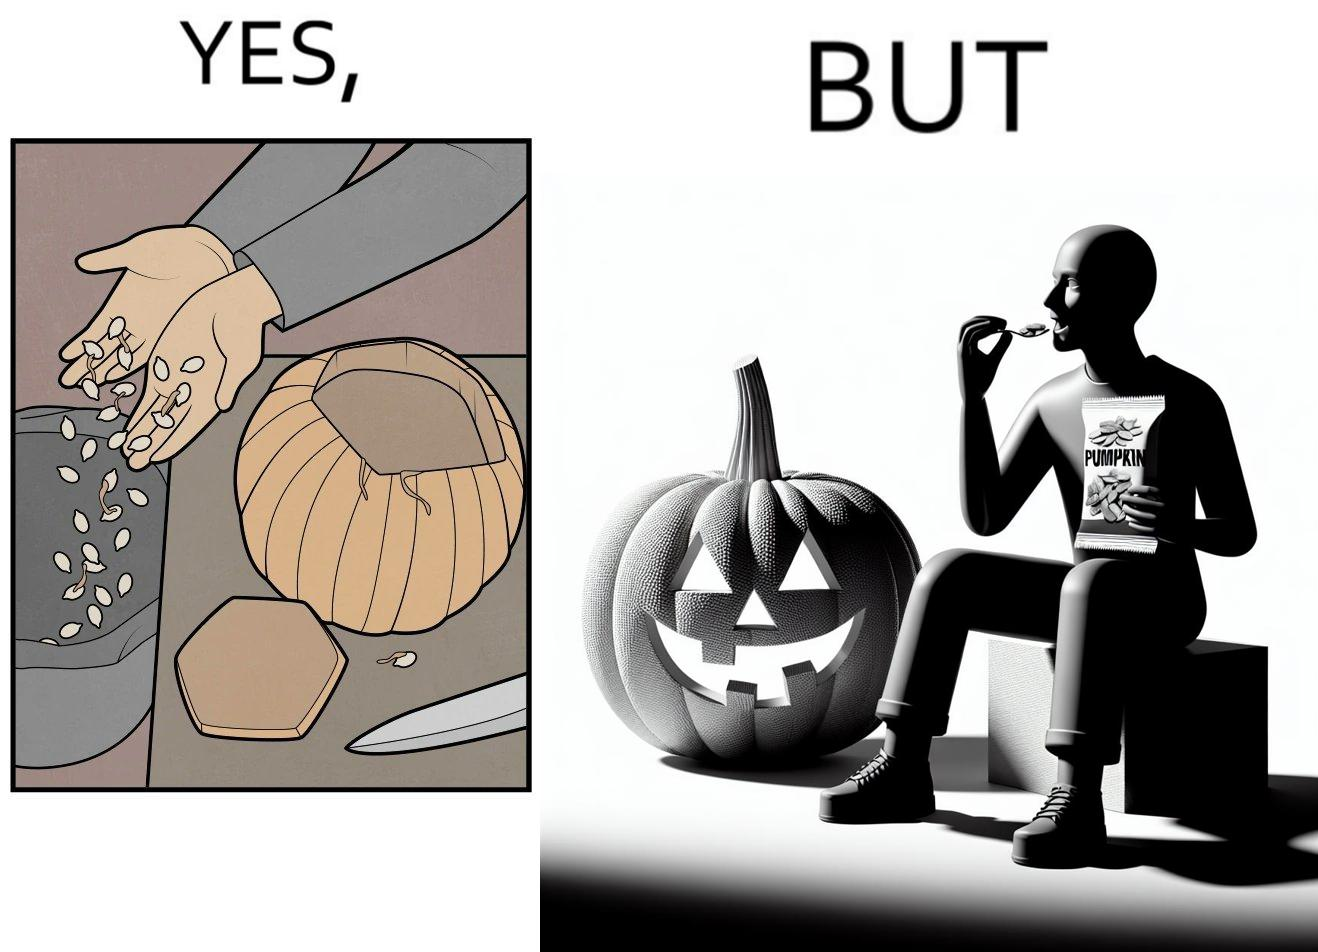Describe the content of this image. The image is ironic, because on one side the same person throws pumpkin seeds out of pumpkin into dustbin when brought at home but he is eating the package pumpkin seeds 